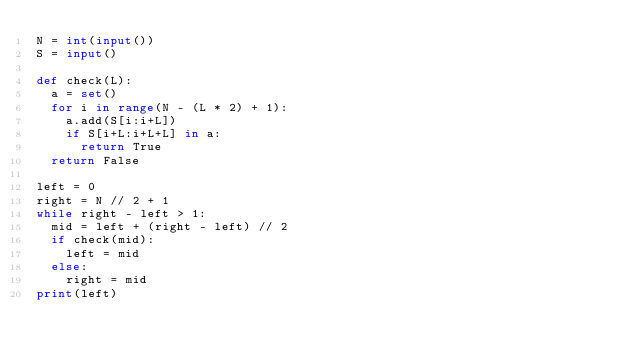<code> <loc_0><loc_0><loc_500><loc_500><_Python_>N = int(input())
S = input()

def check(L):
  a = set()
  for i in range(N - (L * 2) + 1):
    a.add(S[i:i+L])
    if S[i+L:i+L+L] in a:
      return True
  return False

left = 0
right = N // 2 + 1
while right - left > 1:
  mid = left + (right - left) // 2
  if check(mid):
    left = mid
  else:
    right = mid
print(left)</code> 